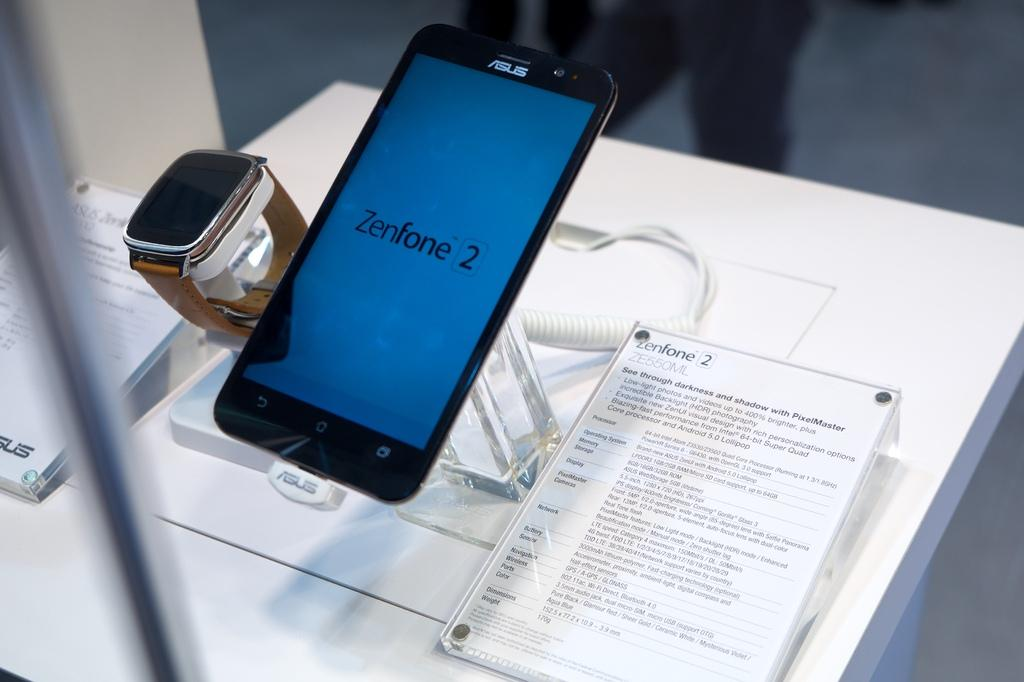<image>
Describe the image concisely. White sign which says Zenfone 2 next to an Asus telephone. 